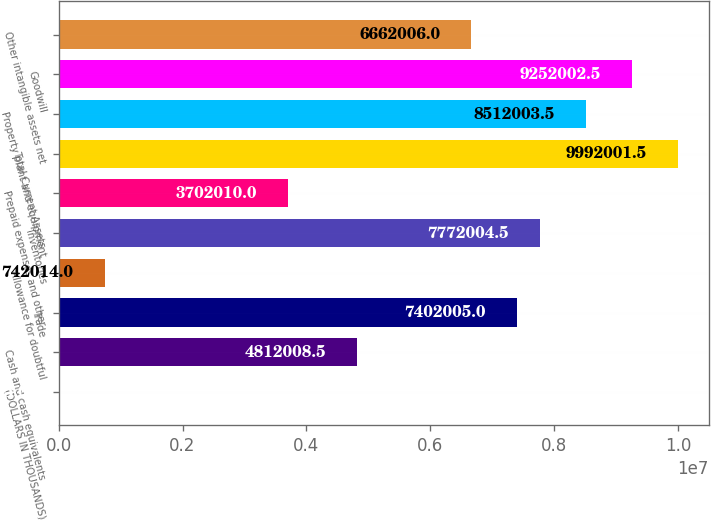Convert chart to OTSL. <chart><loc_0><loc_0><loc_500><loc_500><bar_chart><fcel>(DOLLARS IN THOUSANDS)<fcel>Cash and cash equivalents<fcel>Trade<fcel>Allowance for doubtful<fcel>Inventories<fcel>Prepaid expenses and other<fcel>Total Current Assets<fcel>Property plant and equipment<fcel>Goodwill<fcel>Other intangible assets net<nl><fcel>2015<fcel>4.81201e+06<fcel>7.402e+06<fcel>742014<fcel>7.772e+06<fcel>3.70201e+06<fcel>9.992e+06<fcel>8.512e+06<fcel>9.252e+06<fcel>6.66201e+06<nl></chart> 